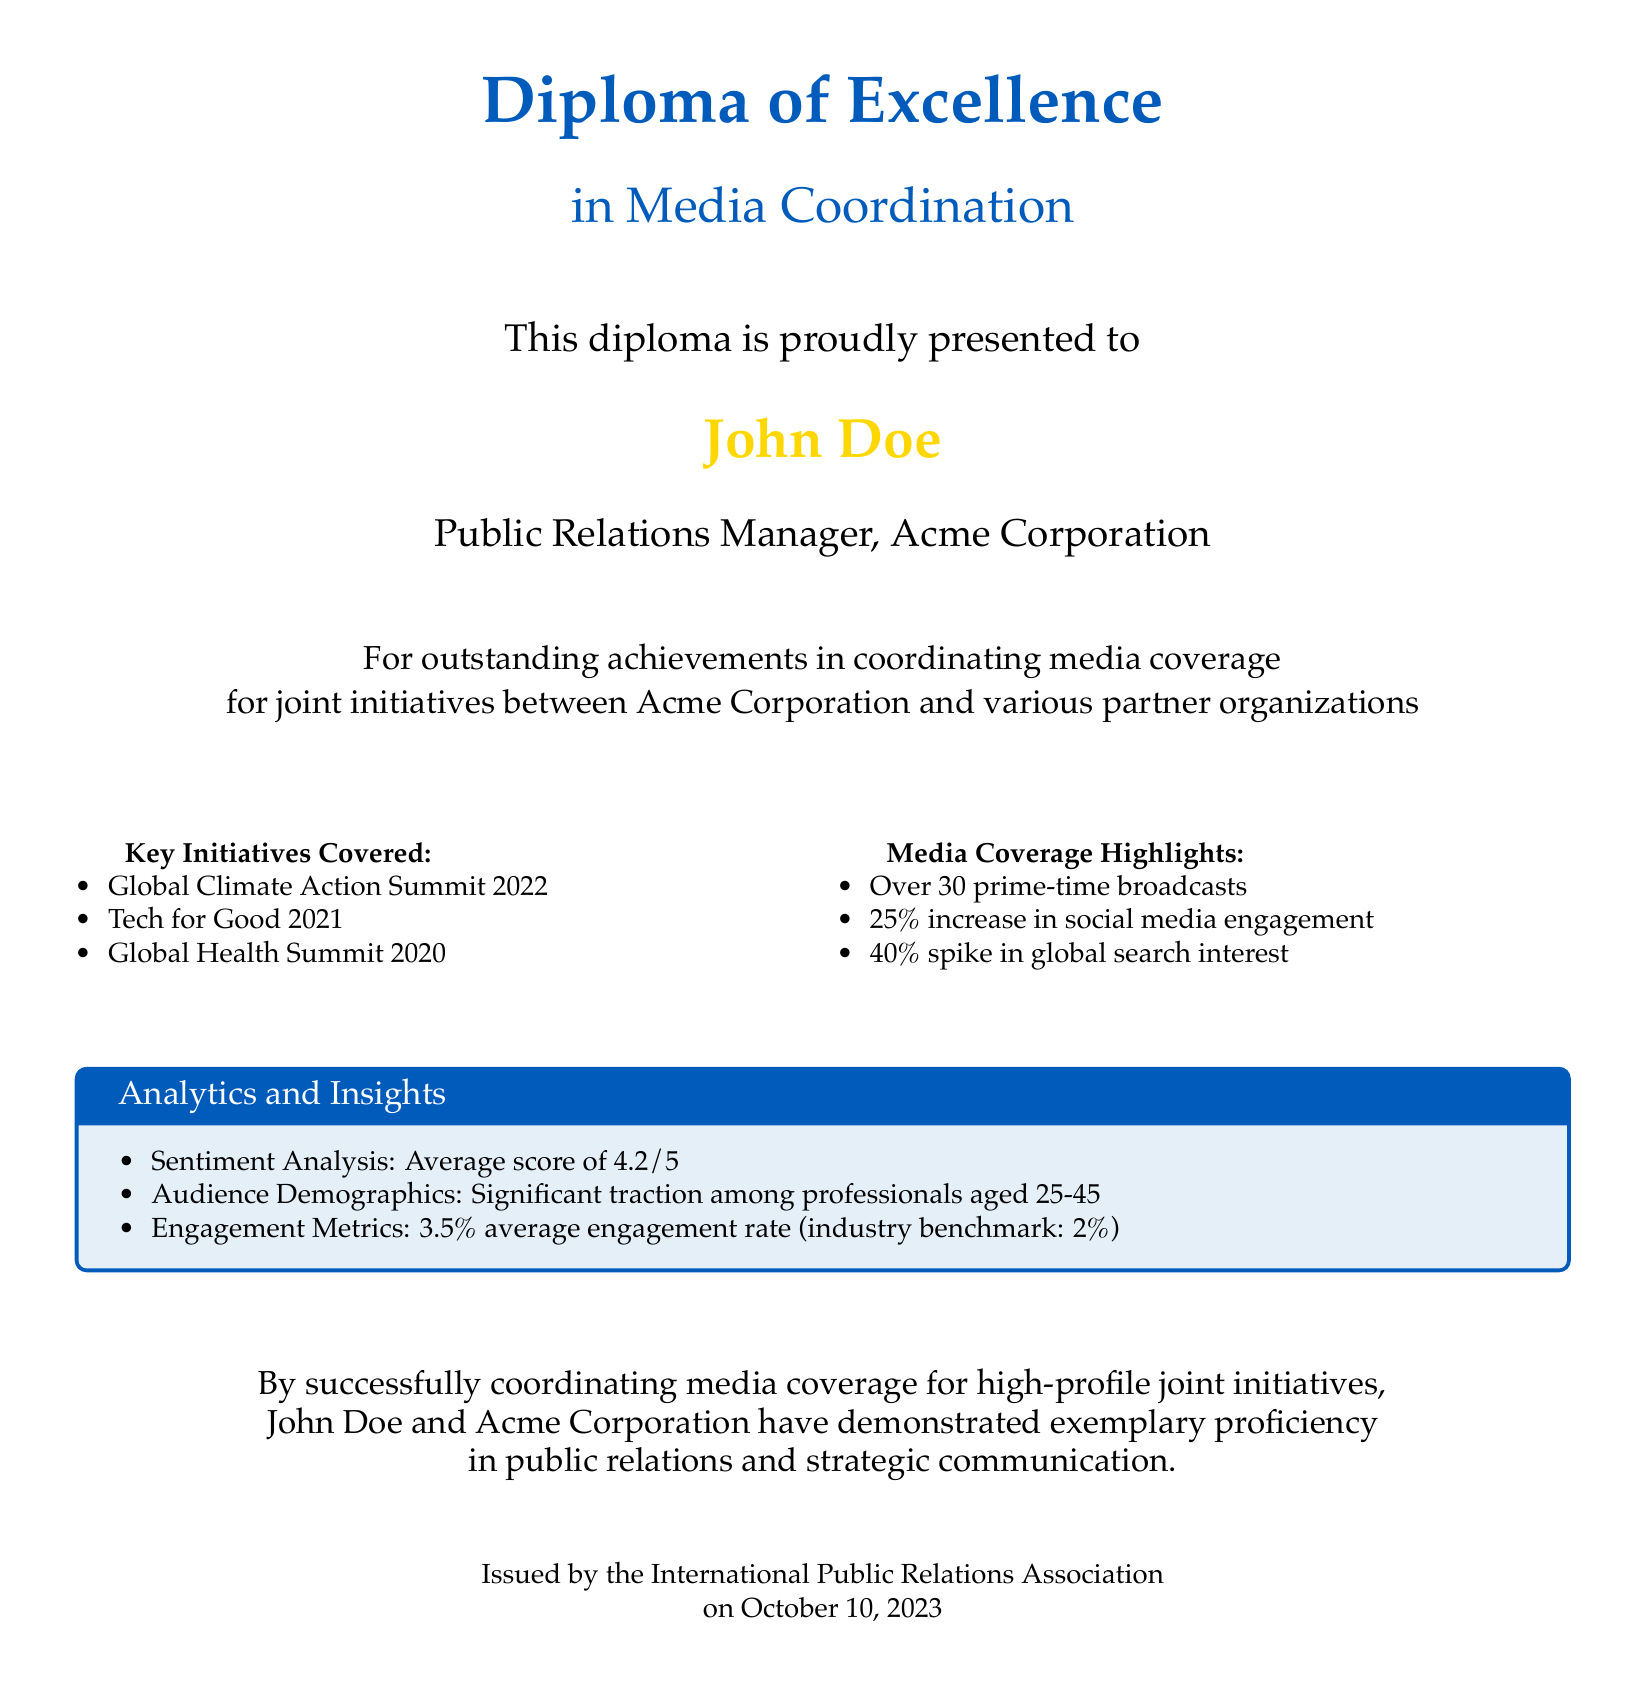What is the title of the diploma? The title of the diploma is prominently displayed at the top of the document.
Answer: Diploma of Excellence Who received the diploma? The recipient's name is highlighted in the center of the document.
Answer: John Doe What position does the recipient hold? The document states the position of the recipient beneath their name.
Answer: Public Relations Manager When was the diploma issued? The date is included in the footer of the document.
Answer: October 10, 2023 How many key initiatives are mentioned? The number of key initiatives can be counted in the "Key Initiatives Covered" section.
Answer: Three What was the increase in social media engagement? This information is found in the "Media Coverage Highlights" section.
Answer: 25% What was the average sentiment analysis score? The score is provided in the "Analytics and Insights" box.
Answer: 4.2/5 What is the average engagement rate mentioned? This metric is specified in the "Analytics and Insights" section of the document.
Answer: 3.5% Which summits are highlighted as key initiatives? The specific summits can be listed from the document.
Answer: Global Climate Action Summit 2022, Tech for Good 2021, Global Health Summit 2020 What organization issued the diploma? The issuing organization is stated at the bottom of the document.
Answer: International Public Relations Association 